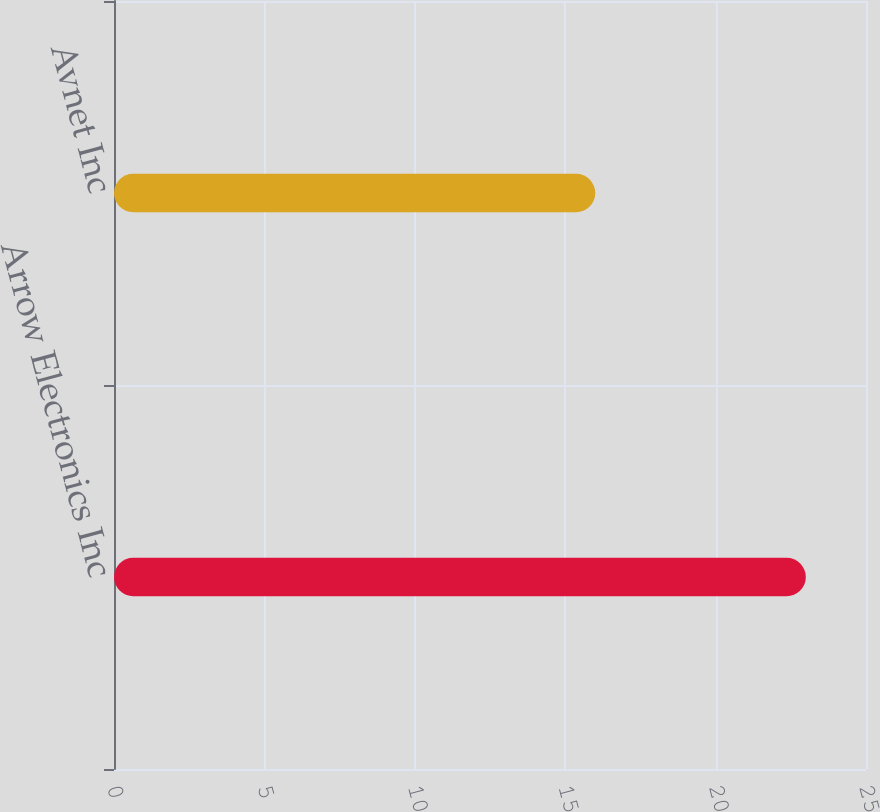Convert chart to OTSL. <chart><loc_0><loc_0><loc_500><loc_500><bar_chart><fcel>Arrow Electronics Inc<fcel>Avnet Inc<nl><fcel>23<fcel>16<nl></chart> 